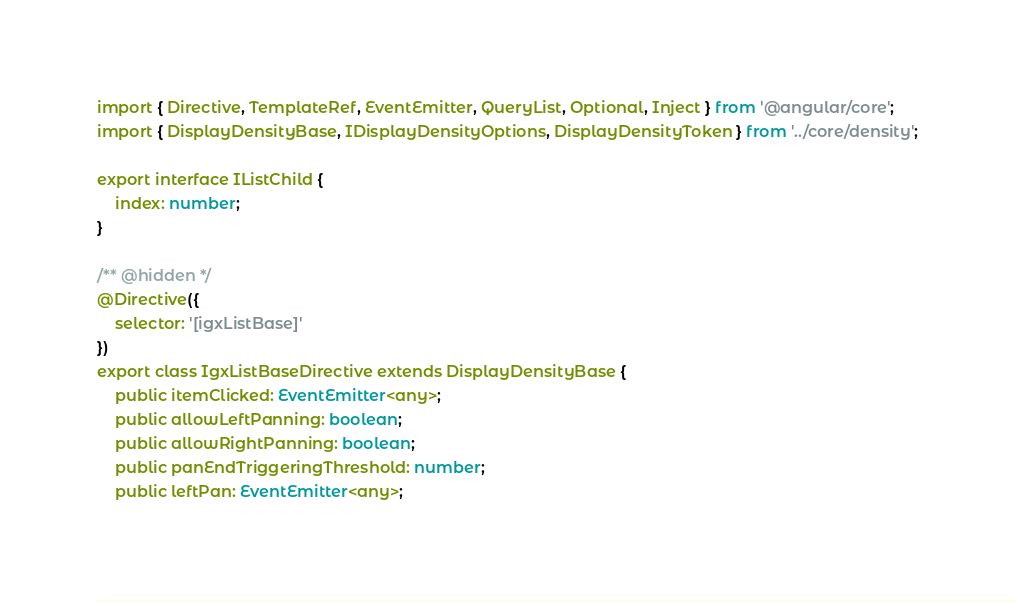<code> <loc_0><loc_0><loc_500><loc_500><_TypeScript_>import { Directive, TemplateRef, EventEmitter, QueryList, Optional, Inject } from '@angular/core';
import { DisplayDensityBase, IDisplayDensityOptions, DisplayDensityToken } from '../core/density';

export interface IListChild {
    index: number;
}

/** @hidden */
@Directive({
    selector: '[igxListBase]'
})
export class IgxListBaseDirective extends DisplayDensityBase {
    public itemClicked: EventEmitter<any>;
    public allowLeftPanning: boolean;
    public allowRightPanning: boolean;
    public panEndTriggeringThreshold: number;
    public leftPan: EventEmitter<any>;</code> 